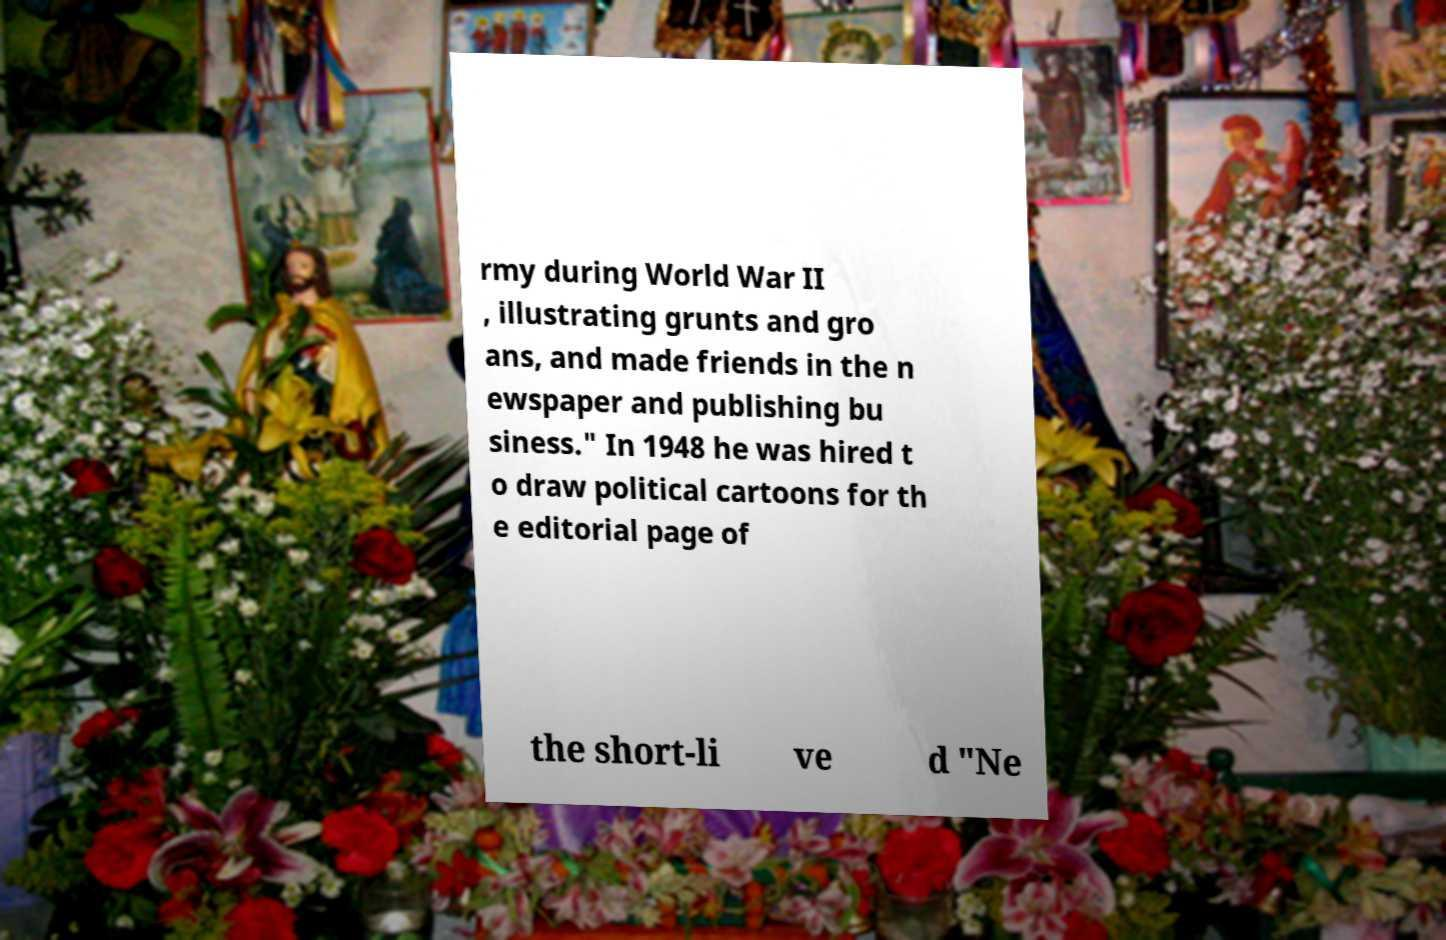Please read and relay the text visible in this image. What does it say? rmy during World War II , illustrating grunts and gro ans, and made friends in the n ewspaper and publishing bu siness." In 1948 he was hired t o draw political cartoons for th e editorial page of the short-li ve d "Ne 